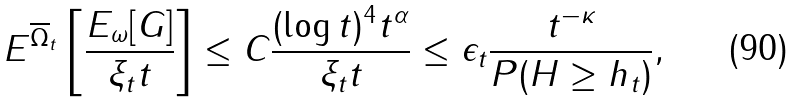<formula> <loc_0><loc_0><loc_500><loc_500>E ^ { \overline { \Omega } _ { t } } \left [ \frac { E _ { \omega } [ G ] } { \xi _ { t } t } \right ] \leq C \frac { ( \log t ) ^ { 4 } t ^ { \alpha } } { \xi _ { t } t } \leq \epsilon _ { t } \frac { t ^ { - \kappa } } { P ( H \geq h _ { t } ) } ,</formula> 